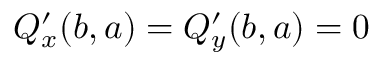Convert formula to latex. <formula><loc_0><loc_0><loc_500><loc_500>Q _ { x } ^ { \prime } ( b , a ) = Q _ { y } ^ { \prime } ( b , a ) = 0</formula> 